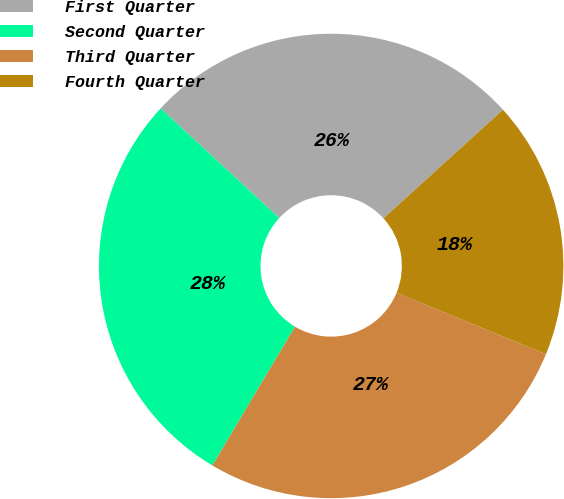Convert chart. <chart><loc_0><loc_0><loc_500><loc_500><pie_chart><fcel>First Quarter<fcel>Second Quarter<fcel>Third Quarter<fcel>Fourth Quarter<nl><fcel>26.39%<fcel>28.32%<fcel>27.35%<fcel>17.95%<nl></chart> 